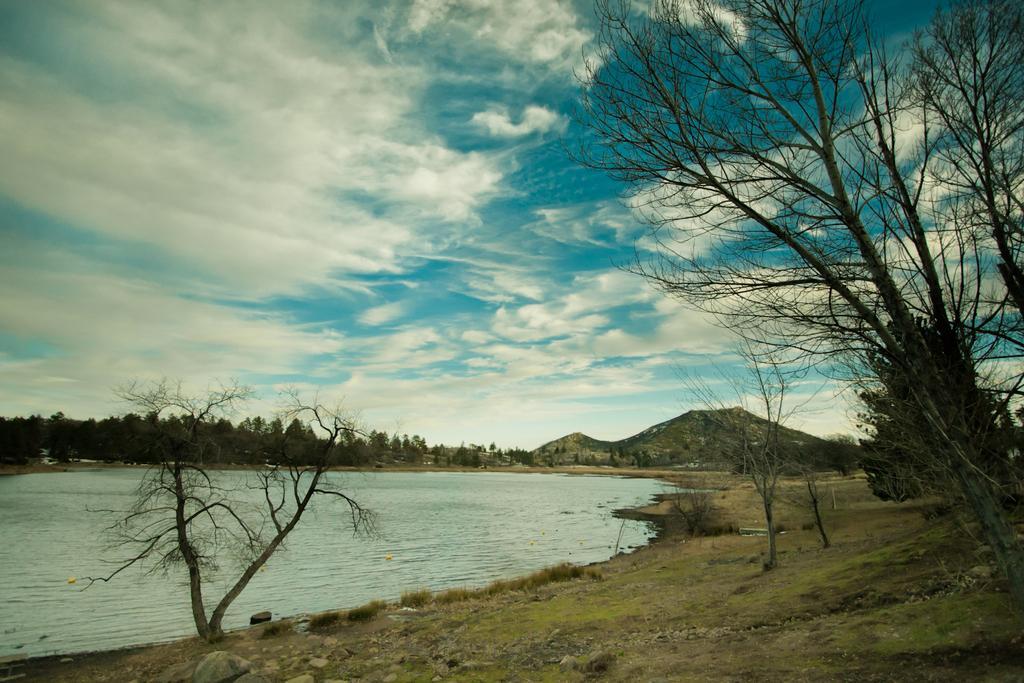Describe this image in one or two sentences. In this image I can see an open ground and on it I can see number of trees. In the centre I can see water. In the background I can see mountains, clouds and the sky. 